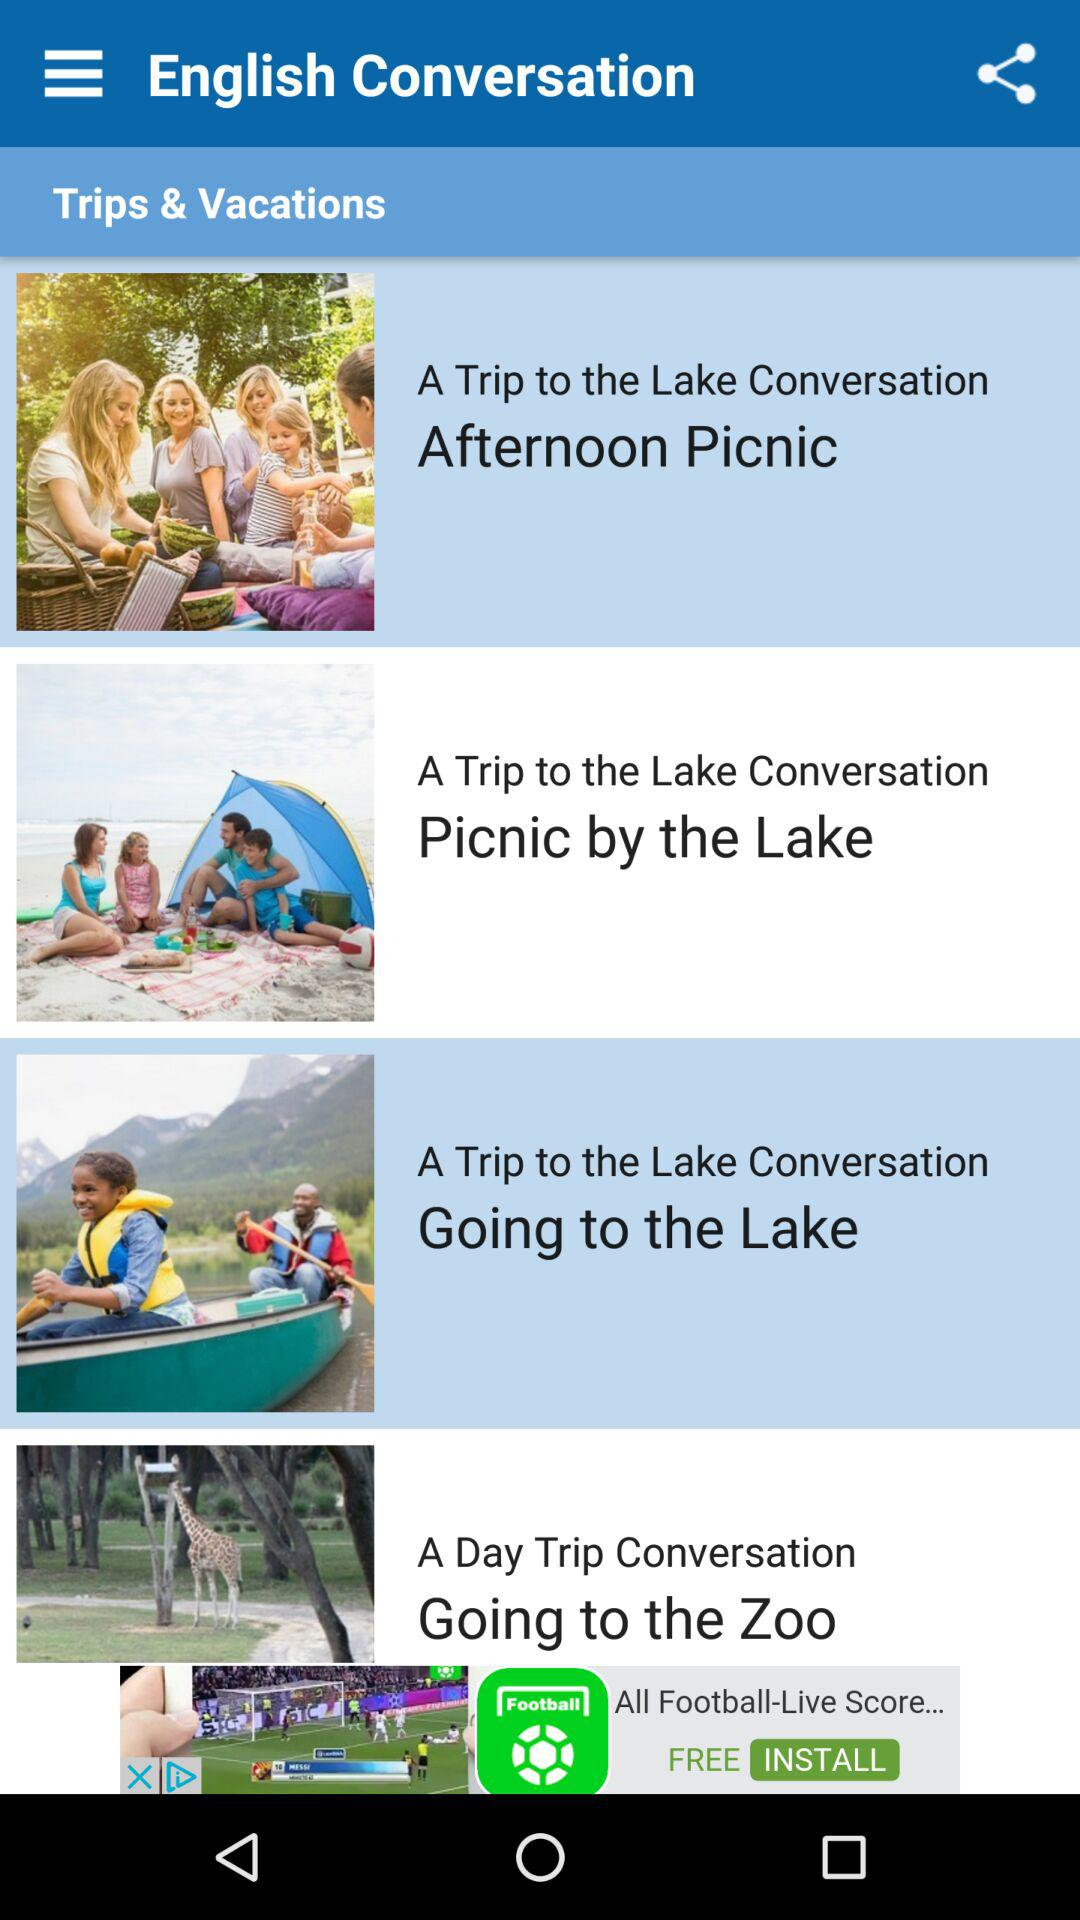How many conversation topics are there about a trip to the lake?
Answer the question using a single word or phrase. 3 